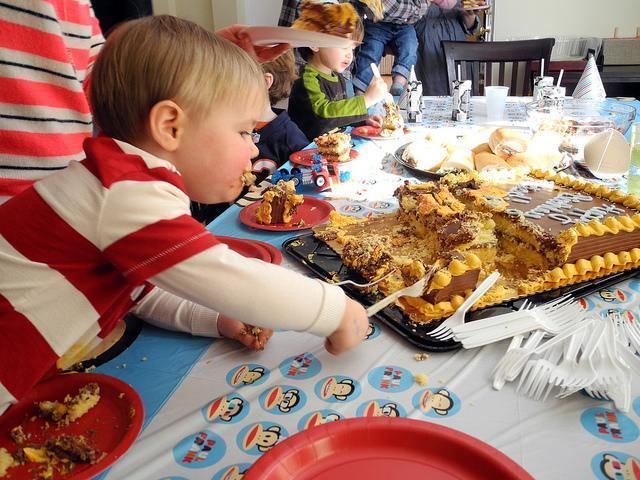How many people are in the picture?
Give a very brief answer. 6. 